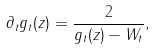Convert formula to latex. <formula><loc_0><loc_0><loc_500><loc_500>\partial _ { t } g _ { t } ( z ) = \frac { 2 } { g _ { t } ( z ) - W _ { t } } ,</formula> 